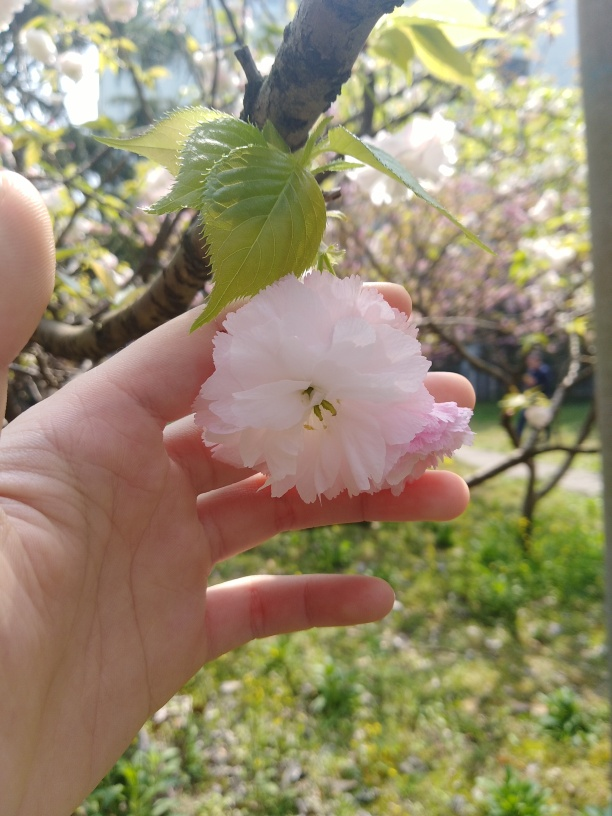What type of flower is this and can you tell me about it? This appears to be a cherry blossom, likely from a Prunus serrulata, also known as a Japanese cherry tree. It's known for its vibrant bloom in spring, signifying beauty and the transient nature of life, celebrated during cherry blossom festivals around the world. What's the significance of cherry blossoms in Japanese culture? In Japanese culture, cherry blossoms, or 'sakura,' symbolize the ephemeral nature of life due to their short blooming period. They're also associated with 'mono no aware,' a concept that reflects the bittersweet awareness of impermanence. The blossoms are celebrated during 'hanami,' where people gather to view the flowers and enjoy the beauty of life. 